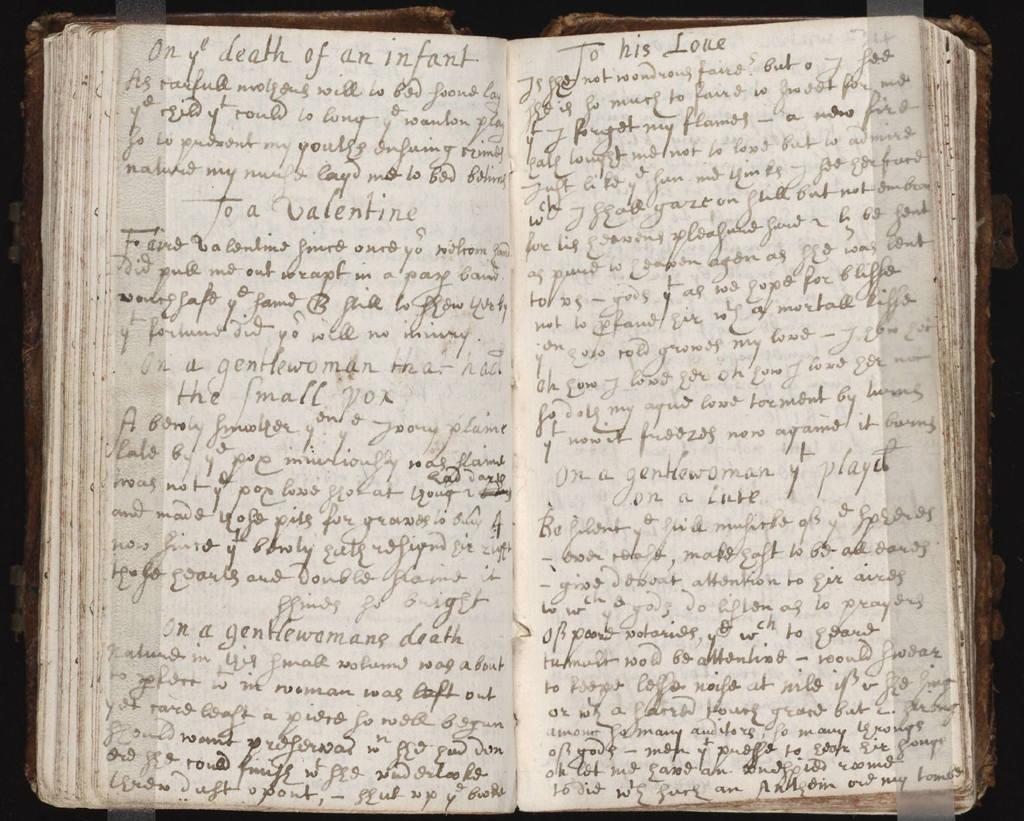What is the first line on the left hand page?
Offer a terse response. On ye death of an infant. What is the heading on the right page?
Keep it short and to the point. To his love. 